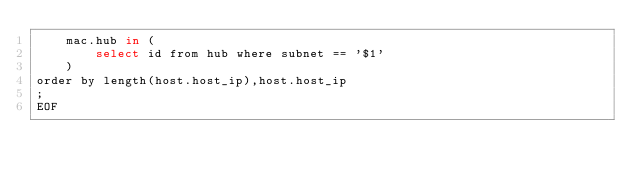<code> <loc_0><loc_0><loc_500><loc_500><_Bash_>    mac.hub in (
        select id from hub where subnet == '$1'
    )
order by length(host.host_ip),host.host_ip
;
EOF
</code> 